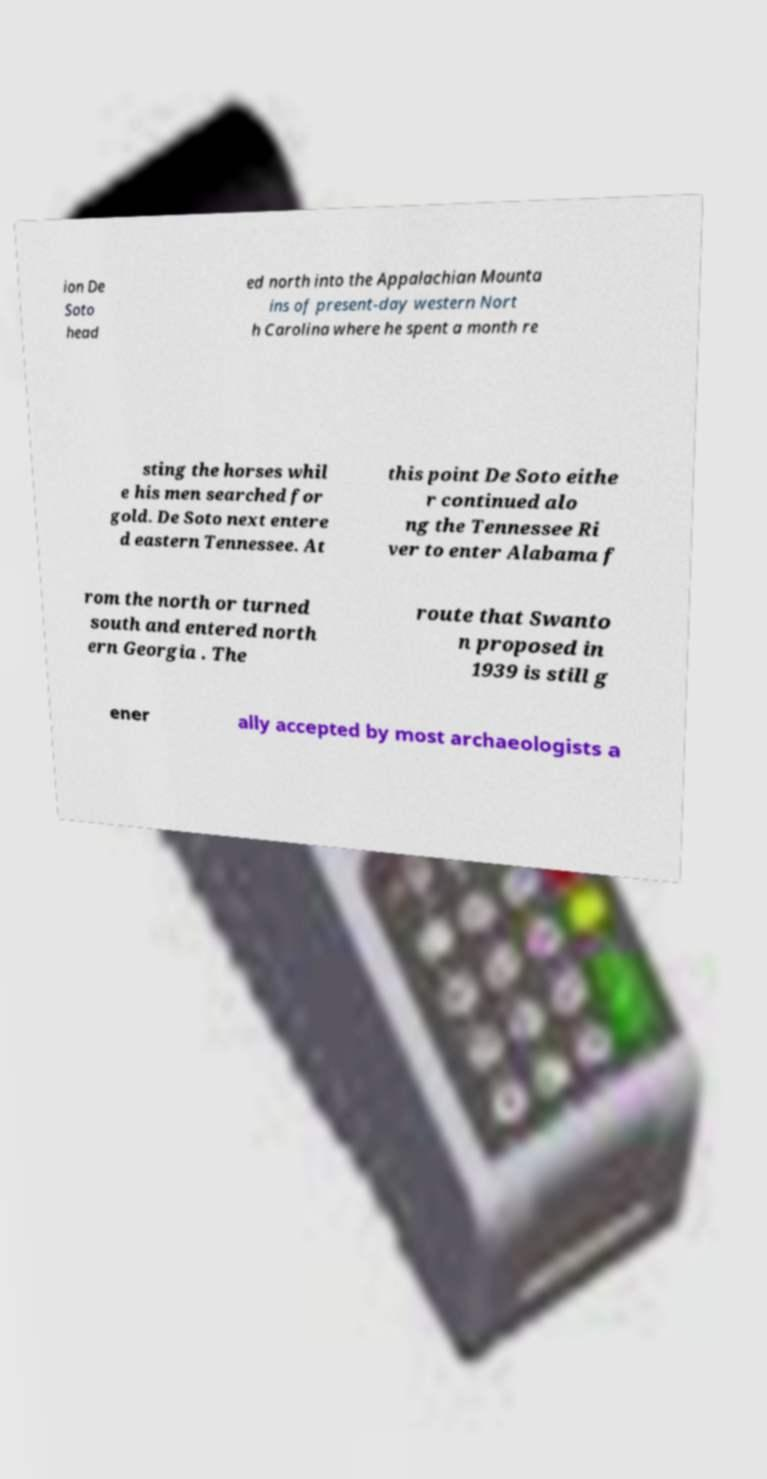I need the written content from this picture converted into text. Can you do that? ion De Soto head ed north into the Appalachian Mounta ins of present-day western Nort h Carolina where he spent a month re sting the horses whil e his men searched for gold. De Soto next entere d eastern Tennessee. At this point De Soto eithe r continued alo ng the Tennessee Ri ver to enter Alabama f rom the north or turned south and entered north ern Georgia . The route that Swanto n proposed in 1939 is still g ener ally accepted by most archaeologists a 